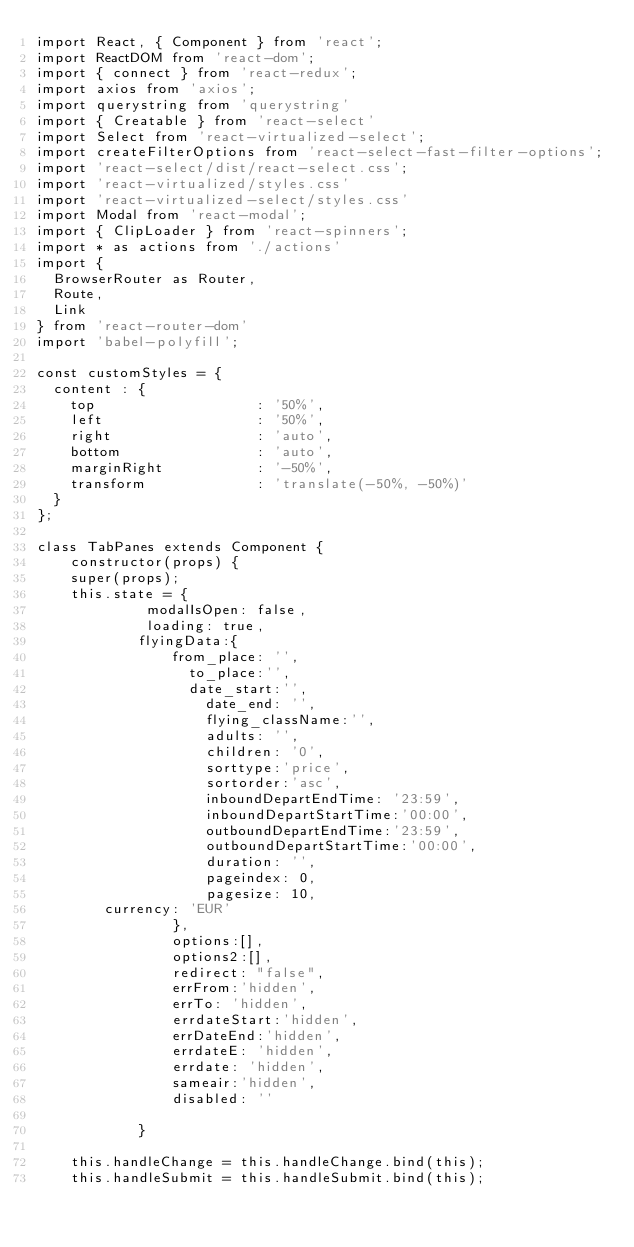<code> <loc_0><loc_0><loc_500><loc_500><_JavaScript_>import React, { Component } from 'react';
import ReactDOM from 'react-dom';
import { connect } from 'react-redux';
import axios from 'axios';
import querystring from 'querystring'
import { Creatable } from 'react-select'
import Select from 'react-virtualized-select';
import createFilterOptions from 'react-select-fast-filter-options';
import 'react-select/dist/react-select.css';
import 'react-virtualized/styles.css'
import 'react-virtualized-select/styles.css'
import Modal from 'react-modal';
import { ClipLoader } from 'react-spinners';
import * as actions from './actions'
import {
  BrowserRouter as Router,
  Route,
  Link
} from 'react-router-dom'
import 'babel-polyfill';

const customStyles = {
  content : {
    top                   : '50%',
    left                  : '50%',
    right                 : 'auto',
    bottom                : 'auto',
    marginRight           : '-50%',
    transform             : 'translate(-50%, -50%)'
  }
};

class TabPanes extends Component {
    constructor(props) {
    super(props);
    this.state = {
             modalIsOpen: false,
             loading: true,
            flyingData:{
                from_place: '',
                  to_place:'',
                  date_start:'',
                    date_end: '',
                    flying_className:'',
                    adults: '',
                    children: '0',
                    sorttype:'price',
                    sortorder:'asc',
                    inboundDepartEndTime: '23:59',
                    inboundDepartStartTime:'00:00',
                    outboundDepartEndTime:'23:59',
                    outboundDepartStartTime:'00:00',
                    duration: '',
                    pageindex: 0,
                    pagesize: 10,
		    currency: 'EUR'
                },
                options:[],
                options2:[],
                redirect: "false",
                errFrom:'hidden',
                errTo: 'hidden',
                errdateStart:'hidden',
                errDateEnd:'hidden',
                errdateE: 'hidden',
                errdate: 'hidden',
                sameair:'hidden',
                disabled: ''
                
            }

    this.handleChange = this.handleChange.bind(this);
    this.handleSubmit = this.handleSubmit.bind(this);</code> 